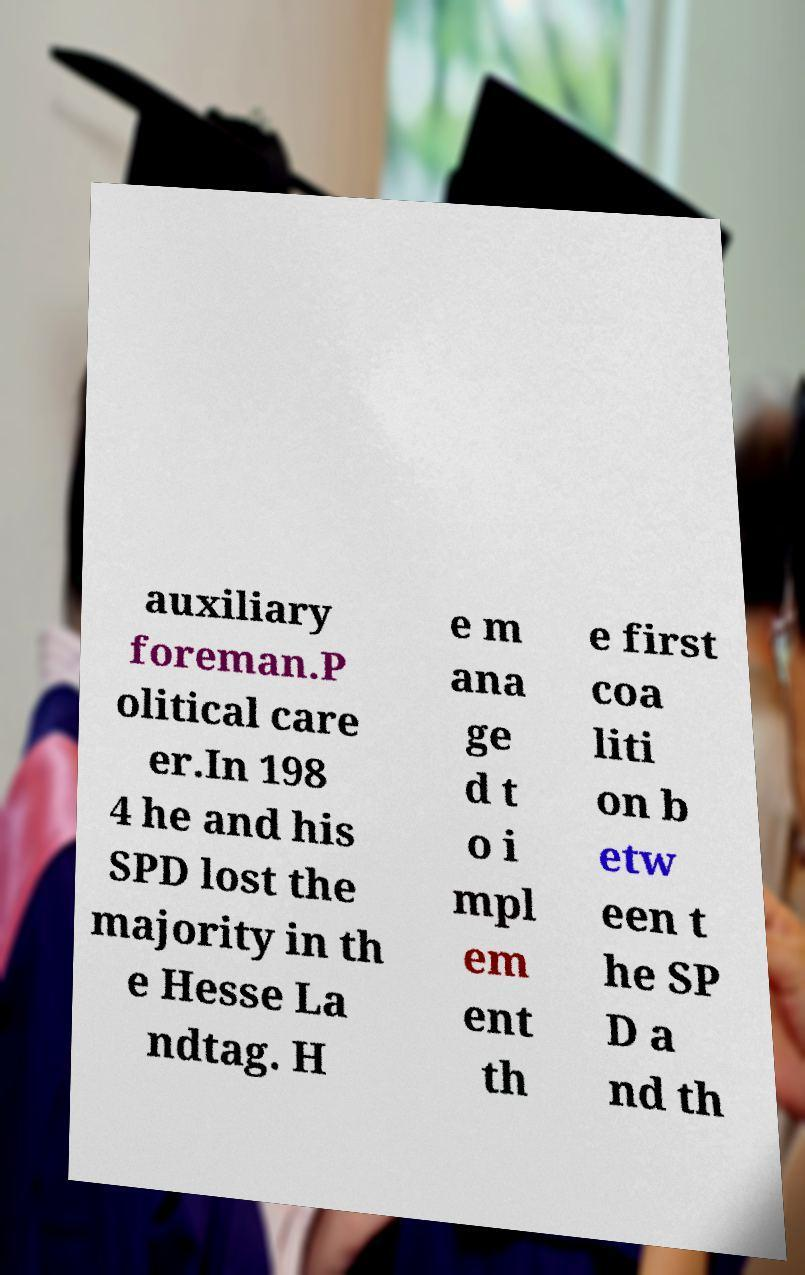Can you read and provide the text displayed in the image?This photo seems to have some interesting text. Can you extract and type it out for me? auxiliary foreman.P olitical care er.In 198 4 he and his SPD lost the majority in th e Hesse La ndtag. H e m ana ge d t o i mpl em ent th e first coa liti on b etw een t he SP D a nd th 